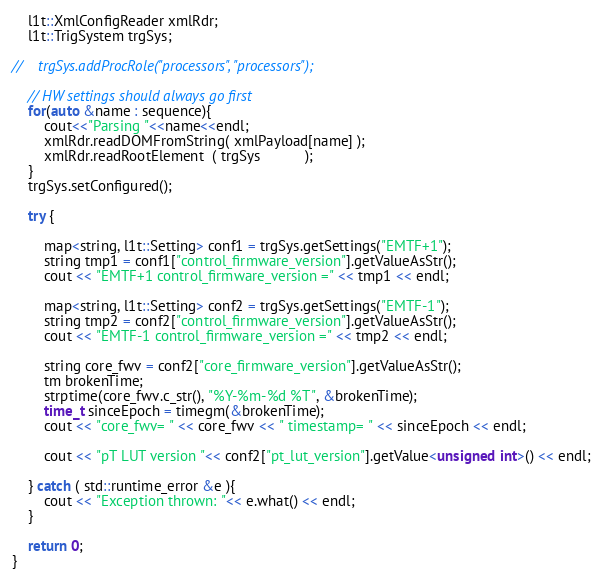<code> <loc_0><loc_0><loc_500><loc_500><_C++_>    l1t::XmlConfigReader xmlRdr;
    l1t::TrigSystem trgSys;

//    trgSys.addProcRole("processors", "processors");

    // HW settings should always go first
    for(auto &name : sequence){
        cout<<"Parsing "<<name<<endl;
        xmlRdr.readDOMFromString( xmlPayload[name] );
        xmlRdr.readRootElement  ( trgSys           );
    }
    trgSys.setConfigured();

    try {

        map<string, l1t::Setting> conf1 = trgSys.getSettings("EMTF+1");
        string tmp1 = conf1["control_firmware_version"].getValueAsStr();
        cout << "EMTF+1 control_firmware_version =" << tmp1 << endl;

        map<string, l1t::Setting> conf2 = trgSys.getSettings("EMTF-1");
        string tmp2 = conf2["control_firmware_version"].getValueAsStr();
        cout << "EMTF-1 control_firmware_version =" << tmp2 << endl;

        string core_fwv = conf2["core_firmware_version"].getValueAsStr();
        tm brokenTime;
        strptime(core_fwv.c_str(), "%Y-%m-%d %T", &brokenTime);
        time_t sinceEpoch = timegm(&brokenTime);
        cout << "core_fwv= " << core_fwv << " timestamp= " << sinceEpoch << endl;

        cout << "pT LUT version "<< conf2["pt_lut_version"].getValue<unsigned int>() << endl;

    } catch ( std::runtime_error &e ){
        cout << "Exception thrown: "<< e.what() << endl;
    }

    return 0;
}

</code> 